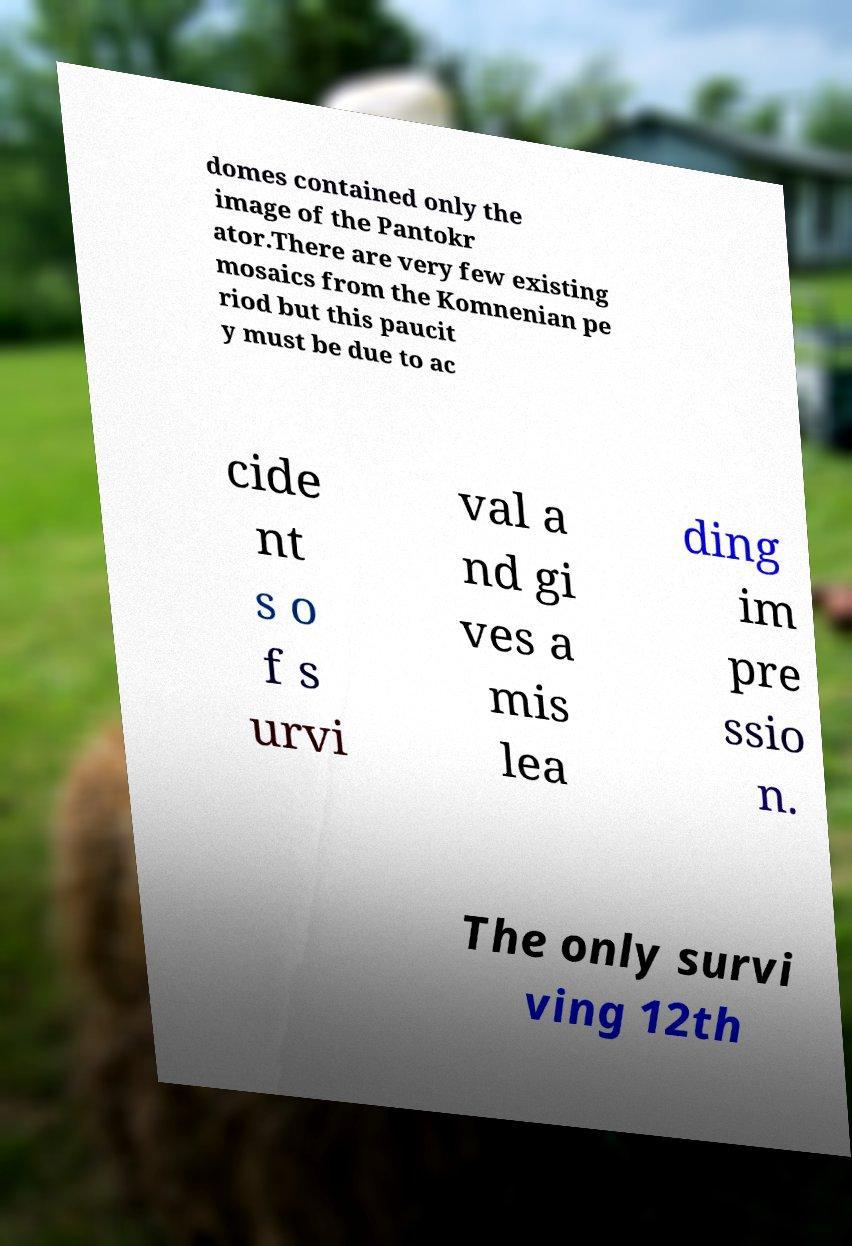For documentation purposes, I need the text within this image transcribed. Could you provide that? domes contained only the image of the Pantokr ator.There are very few existing mosaics from the Komnenian pe riod but this paucit y must be due to ac cide nt s o f s urvi val a nd gi ves a mis lea ding im pre ssio n. The only survi ving 12th 